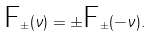Convert formula to latex. <formula><loc_0><loc_0><loc_500><loc_500>\mbox F _ { \pm } ( \nu ) = \pm \mbox F _ { \pm } ( - \nu ) .</formula> 